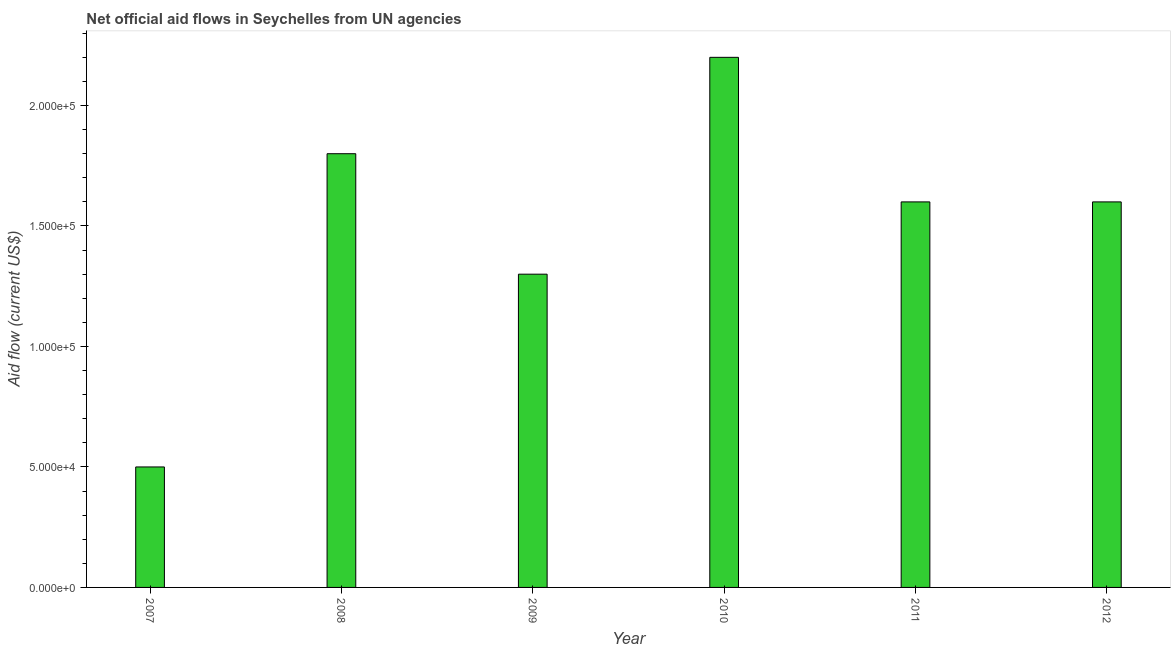What is the title of the graph?
Ensure brevity in your answer.  Net official aid flows in Seychelles from UN agencies. What is the label or title of the X-axis?
Ensure brevity in your answer.  Year. What is the label or title of the Y-axis?
Make the answer very short. Aid flow (current US$). In which year was the net official flows from un agencies minimum?
Offer a very short reply. 2007. What is the sum of the net official flows from un agencies?
Make the answer very short. 9.00e+05. What is the difference between the net official flows from un agencies in 2007 and 2008?
Give a very brief answer. -1.30e+05. What is the average net official flows from un agencies per year?
Make the answer very short. 1.50e+05. What is the ratio of the net official flows from un agencies in 2009 to that in 2011?
Give a very brief answer. 0.81. Is the difference between the net official flows from un agencies in 2007 and 2011 greater than the difference between any two years?
Your response must be concise. No. Is the sum of the net official flows from un agencies in 2009 and 2011 greater than the maximum net official flows from un agencies across all years?
Keep it short and to the point. Yes. Are all the bars in the graph horizontal?
Offer a very short reply. No. What is the Aid flow (current US$) of 2008?
Your answer should be very brief. 1.80e+05. What is the Aid flow (current US$) of 2011?
Provide a succinct answer. 1.60e+05. What is the difference between the Aid flow (current US$) in 2008 and 2011?
Your answer should be compact. 2.00e+04. What is the difference between the Aid flow (current US$) in 2009 and 2010?
Your response must be concise. -9.00e+04. What is the difference between the Aid flow (current US$) in 2009 and 2012?
Your answer should be very brief. -3.00e+04. What is the difference between the Aid flow (current US$) in 2011 and 2012?
Keep it short and to the point. 0. What is the ratio of the Aid flow (current US$) in 2007 to that in 2008?
Your answer should be very brief. 0.28. What is the ratio of the Aid flow (current US$) in 2007 to that in 2009?
Provide a short and direct response. 0.39. What is the ratio of the Aid flow (current US$) in 2007 to that in 2010?
Ensure brevity in your answer.  0.23. What is the ratio of the Aid flow (current US$) in 2007 to that in 2011?
Your answer should be very brief. 0.31. What is the ratio of the Aid flow (current US$) in 2007 to that in 2012?
Provide a short and direct response. 0.31. What is the ratio of the Aid flow (current US$) in 2008 to that in 2009?
Ensure brevity in your answer.  1.39. What is the ratio of the Aid flow (current US$) in 2008 to that in 2010?
Offer a terse response. 0.82. What is the ratio of the Aid flow (current US$) in 2008 to that in 2012?
Make the answer very short. 1.12. What is the ratio of the Aid flow (current US$) in 2009 to that in 2010?
Keep it short and to the point. 0.59. What is the ratio of the Aid flow (current US$) in 2009 to that in 2011?
Ensure brevity in your answer.  0.81. What is the ratio of the Aid flow (current US$) in 2009 to that in 2012?
Give a very brief answer. 0.81. What is the ratio of the Aid flow (current US$) in 2010 to that in 2011?
Your response must be concise. 1.38. What is the ratio of the Aid flow (current US$) in 2010 to that in 2012?
Make the answer very short. 1.38. 